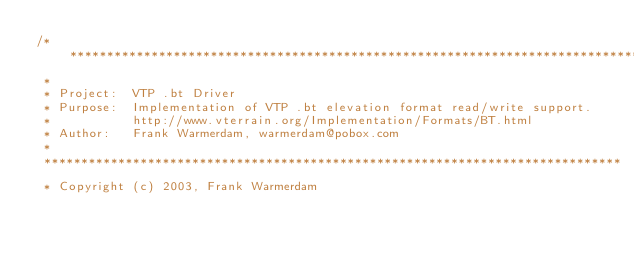Convert code to text. <code><loc_0><loc_0><loc_500><loc_500><_C++_>/******************************************************************************
 *
 * Project:  VTP .bt Driver
 * Purpose:  Implementation of VTP .bt elevation format read/write support.
 *           http://www.vterrain.org/Implementation/Formats/BT.html
 * Author:   Frank Warmerdam, warmerdam@pobox.com
 *
 ******************************************************************************
 * Copyright (c) 2003, Frank Warmerdam</code> 